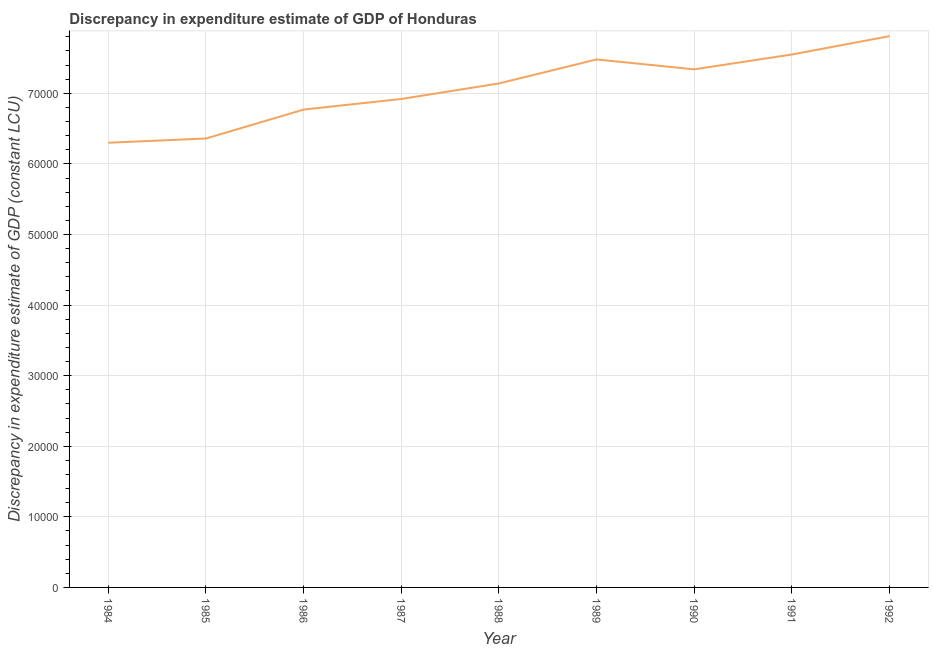What is the discrepancy in expenditure estimate of gdp in 1984?
Offer a very short reply. 6.30e+04. Across all years, what is the maximum discrepancy in expenditure estimate of gdp?
Your response must be concise. 7.81e+04. Across all years, what is the minimum discrepancy in expenditure estimate of gdp?
Provide a short and direct response. 6.30e+04. In which year was the discrepancy in expenditure estimate of gdp minimum?
Ensure brevity in your answer.  1984. What is the sum of the discrepancy in expenditure estimate of gdp?
Keep it short and to the point. 6.37e+05. What is the difference between the discrepancy in expenditure estimate of gdp in 1990 and 1992?
Offer a very short reply. -4700. What is the average discrepancy in expenditure estimate of gdp per year?
Ensure brevity in your answer.  7.07e+04. What is the median discrepancy in expenditure estimate of gdp?
Provide a short and direct response. 7.14e+04. In how many years, is the discrepancy in expenditure estimate of gdp greater than 60000 LCU?
Your answer should be compact. 9. What is the ratio of the discrepancy in expenditure estimate of gdp in 1984 to that in 1992?
Your answer should be compact. 0.81. Is the difference between the discrepancy in expenditure estimate of gdp in 1985 and 1988 greater than the difference between any two years?
Provide a succinct answer. No. What is the difference between the highest and the second highest discrepancy in expenditure estimate of gdp?
Your answer should be very brief. 2600. Is the sum of the discrepancy in expenditure estimate of gdp in 1989 and 1992 greater than the maximum discrepancy in expenditure estimate of gdp across all years?
Give a very brief answer. Yes. What is the difference between the highest and the lowest discrepancy in expenditure estimate of gdp?
Ensure brevity in your answer.  1.51e+04. In how many years, is the discrepancy in expenditure estimate of gdp greater than the average discrepancy in expenditure estimate of gdp taken over all years?
Offer a terse response. 5. How many lines are there?
Provide a succinct answer. 1. Does the graph contain grids?
Provide a short and direct response. Yes. What is the title of the graph?
Your answer should be compact. Discrepancy in expenditure estimate of GDP of Honduras. What is the label or title of the X-axis?
Provide a succinct answer. Year. What is the label or title of the Y-axis?
Provide a short and direct response. Discrepancy in expenditure estimate of GDP (constant LCU). What is the Discrepancy in expenditure estimate of GDP (constant LCU) in 1984?
Your response must be concise. 6.30e+04. What is the Discrepancy in expenditure estimate of GDP (constant LCU) in 1985?
Your answer should be compact. 6.36e+04. What is the Discrepancy in expenditure estimate of GDP (constant LCU) of 1986?
Your answer should be very brief. 6.77e+04. What is the Discrepancy in expenditure estimate of GDP (constant LCU) in 1987?
Your response must be concise. 6.92e+04. What is the Discrepancy in expenditure estimate of GDP (constant LCU) of 1988?
Your answer should be very brief. 7.14e+04. What is the Discrepancy in expenditure estimate of GDP (constant LCU) in 1989?
Your answer should be very brief. 7.48e+04. What is the Discrepancy in expenditure estimate of GDP (constant LCU) in 1990?
Your answer should be compact. 7.34e+04. What is the Discrepancy in expenditure estimate of GDP (constant LCU) of 1991?
Give a very brief answer. 7.55e+04. What is the Discrepancy in expenditure estimate of GDP (constant LCU) in 1992?
Your answer should be very brief. 7.81e+04. What is the difference between the Discrepancy in expenditure estimate of GDP (constant LCU) in 1984 and 1985?
Ensure brevity in your answer.  -600. What is the difference between the Discrepancy in expenditure estimate of GDP (constant LCU) in 1984 and 1986?
Ensure brevity in your answer.  -4700. What is the difference between the Discrepancy in expenditure estimate of GDP (constant LCU) in 1984 and 1987?
Give a very brief answer. -6200. What is the difference between the Discrepancy in expenditure estimate of GDP (constant LCU) in 1984 and 1988?
Keep it short and to the point. -8400. What is the difference between the Discrepancy in expenditure estimate of GDP (constant LCU) in 1984 and 1989?
Provide a short and direct response. -1.18e+04. What is the difference between the Discrepancy in expenditure estimate of GDP (constant LCU) in 1984 and 1990?
Your answer should be very brief. -1.04e+04. What is the difference between the Discrepancy in expenditure estimate of GDP (constant LCU) in 1984 and 1991?
Offer a terse response. -1.25e+04. What is the difference between the Discrepancy in expenditure estimate of GDP (constant LCU) in 1984 and 1992?
Your response must be concise. -1.51e+04. What is the difference between the Discrepancy in expenditure estimate of GDP (constant LCU) in 1985 and 1986?
Provide a short and direct response. -4100. What is the difference between the Discrepancy in expenditure estimate of GDP (constant LCU) in 1985 and 1987?
Offer a very short reply. -5600. What is the difference between the Discrepancy in expenditure estimate of GDP (constant LCU) in 1985 and 1988?
Your response must be concise. -7800. What is the difference between the Discrepancy in expenditure estimate of GDP (constant LCU) in 1985 and 1989?
Provide a short and direct response. -1.12e+04. What is the difference between the Discrepancy in expenditure estimate of GDP (constant LCU) in 1985 and 1990?
Keep it short and to the point. -9800. What is the difference between the Discrepancy in expenditure estimate of GDP (constant LCU) in 1985 and 1991?
Provide a succinct answer. -1.19e+04. What is the difference between the Discrepancy in expenditure estimate of GDP (constant LCU) in 1985 and 1992?
Ensure brevity in your answer.  -1.45e+04. What is the difference between the Discrepancy in expenditure estimate of GDP (constant LCU) in 1986 and 1987?
Your response must be concise. -1500. What is the difference between the Discrepancy in expenditure estimate of GDP (constant LCU) in 1986 and 1988?
Offer a terse response. -3700. What is the difference between the Discrepancy in expenditure estimate of GDP (constant LCU) in 1986 and 1989?
Your response must be concise. -7100. What is the difference between the Discrepancy in expenditure estimate of GDP (constant LCU) in 1986 and 1990?
Keep it short and to the point. -5700. What is the difference between the Discrepancy in expenditure estimate of GDP (constant LCU) in 1986 and 1991?
Keep it short and to the point. -7800. What is the difference between the Discrepancy in expenditure estimate of GDP (constant LCU) in 1986 and 1992?
Ensure brevity in your answer.  -1.04e+04. What is the difference between the Discrepancy in expenditure estimate of GDP (constant LCU) in 1987 and 1988?
Your response must be concise. -2200. What is the difference between the Discrepancy in expenditure estimate of GDP (constant LCU) in 1987 and 1989?
Offer a terse response. -5600. What is the difference between the Discrepancy in expenditure estimate of GDP (constant LCU) in 1987 and 1990?
Keep it short and to the point. -4200. What is the difference between the Discrepancy in expenditure estimate of GDP (constant LCU) in 1987 and 1991?
Make the answer very short. -6300. What is the difference between the Discrepancy in expenditure estimate of GDP (constant LCU) in 1987 and 1992?
Offer a very short reply. -8900. What is the difference between the Discrepancy in expenditure estimate of GDP (constant LCU) in 1988 and 1989?
Make the answer very short. -3400. What is the difference between the Discrepancy in expenditure estimate of GDP (constant LCU) in 1988 and 1990?
Your answer should be compact. -2000. What is the difference between the Discrepancy in expenditure estimate of GDP (constant LCU) in 1988 and 1991?
Your response must be concise. -4100. What is the difference between the Discrepancy in expenditure estimate of GDP (constant LCU) in 1988 and 1992?
Provide a short and direct response. -6700. What is the difference between the Discrepancy in expenditure estimate of GDP (constant LCU) in 1989 and 1990?
Your answer should be very brief. 1400. What is the difference between the Discrepancy in expenditure estimate of GDP (constant LCU) in 1989 and 1991?
Provide a short and direct response. -700. What is the difference between the Discrepancy in expenditure estimate of GDP (constant LCU) in 1989 and 1992?
Offer a terse response. -3300. What is the difference between the Discrepancy in expenditure estimate of GDP (constant LCU) in 1990 and 1991?
Offer a terse response. -2100. What is the difference between the Discrepancy in expenditure estimate of GDP (constant LCU) in 1990 and 1992?
Keep it short and to the point. -4700. What is the difference between the Discrepancy in expenditure estimate of GDP (constant LCU) in 1991 and 1992?
Your response must be concise. -2600. What is the ratio of the Discrepancy in expenditure estimate of GDP (constant LCU) in 1984 to that in 1985?
Offer a terse response. 0.99. What is the ratio of the Discrepancy in expenditure estimate of GDP (constant LCU) in 1984 to that in 1986?
Ensure brevity in your answer.  0.93. What is the ratio of the Discrepancy in expenditure estimate of GDP (constant LCU) in 1984 to that in 1987?
Offer a very short reply. 0.91. What is the ratio of the Discrepancy in expenditure estimate of GDP (constant LCU) in 1984 to that in 1988?
Your response must be concise. 0.88. What is the ratio of the Discrepancy in expenditure estimate of GDP (constant LCU) in 1984 to that in 1989?
Ensure brevity in your answer.  0.84. What is the ratio of the Discrepancy in expenditure estimate of GDP (constant LCU) in 1984 to that in 1990?
Your answer should be compact. 0.86. What is the ratio of the Discrepancy in expenditure estimate of GDP (constant LCU) in 1984 to that in 1991?
Your answer should be compact. 0.83. What is the ratio of the Discrepancy in expenditure estimate of GDP (constant LCU) in 1984 to that in 1992?
Provide a succinct answer. 0.81. What is the ratio of the Discrepancy in expenditure estimate of GDP (constant LCU) in 1985 to that in 1986?
Provide a short and direct response. 0.94. What is the ratio of the Discrepancy in expenditure estimate of GDP (constant LCU) in 1985 to that in 1987?
Provide a short and direct response. 0.92. What is the ratio of the Discrepancy in expenditure estimate of GDP (constant LCU) in 1985 to that in 1988?
Your answer should be very brief. 0.89. What is the ratio of the Discrepancy in expenditure estimate of GDP (constant LCU) in 1985 to that in 1990?
Ensure brevity in your answer.  0.87. What is the ratio of the Discrepancy in expenditure estimate of GDP (constant LCU) in 1985 to that in 1991?
Keep it short and to the point. 0.84. What is the ratio of the Discrepancy in expenditure estimate of GDP (constant LCU) in 1985 to that in 1992?
Your response must be concise. 0.81. What is the ratio of the Discrepancy in expenditure estimate of GDP (constant LCU) in 1986 to that in 1988?
Keep it short and to the point. 0.95. What is the ratio of the Discrepancy in expenditure estimate of GDP (constant LCU) in 1986 to that in 1989?
Give a very brief answer. 0.91. What is the ratio of the Discrepancy in expenditure estimate of GDP (constant LCU) in 1986 to that in 1990?
Give a very brief answer. 0.92. What is the ratio of the Discrepancy in expenditure estimate of GDP (constant LCU) in 1986 to that in 1991?
Your answer should be very brief. 0.9. What is the ratio of the Discrepancy in expenditure estimate of GDP (constant LCU) in 1986 to that in 1992?
Offer a very short reply. 0.87. What is the ratio of the Discrepancy in expenditure estimate of GDP (constant LCU) in 1987 to that in 1989?
Make the answer very short. 0.93. What is the ratio of the Discrepancy in expenditure estimate of GDP (constant LCU) in 1987 to that in 1990?
Offer a very short reply. 0.94. What is the ratio of the Discrepancy in expenditure estimate of GDP (constant LCU) in 1987 to that in 1991?
Give a very brief answer. 0.92. What is the ratio of the Discrepancy in expenditure estimate of GDP (constant LCU) in 1987 to that in 1992?
Make the answer very short. 0.89. What is the ratio of the Discrepancy in expenditure estimate of GDP (constant LCU) in 1988 to that in 1989?
Make the answer very short. 0.95. What is the ratio of the Discrepancy in expenditure estimate of GDP (constant LCU) in 1988 to that in 1991?
Offer a very short reply. 0.95. What is the ratio of the Discrepancy in expenditure estimate of GDP (constant LCU) in 1988 to that in 1992?
Your response must be concise. 0.91. What is the ratio of the Discrepancy in expenditure estimate of GDP (constant LCU) in 1989 to that in 1991?
Make the answer very short. 0.99. What is the ratio of the Discrepancy in expenditure estimate of GDP (constant LCU) in 1989 to that in 1992?
Keep it short and to the point. 0.96. What is the ratio of the Discrepancy in expenditure estimate of GDP (constant LCU) in 1990 to that in 1992?
Provide a succinct answer. 0.94. What is the ratio of the Discrepancy in expenditure estimate of GDP (constant LCU) in 1991 to that in 1992?
Keep it short and to the point. 0.97. 